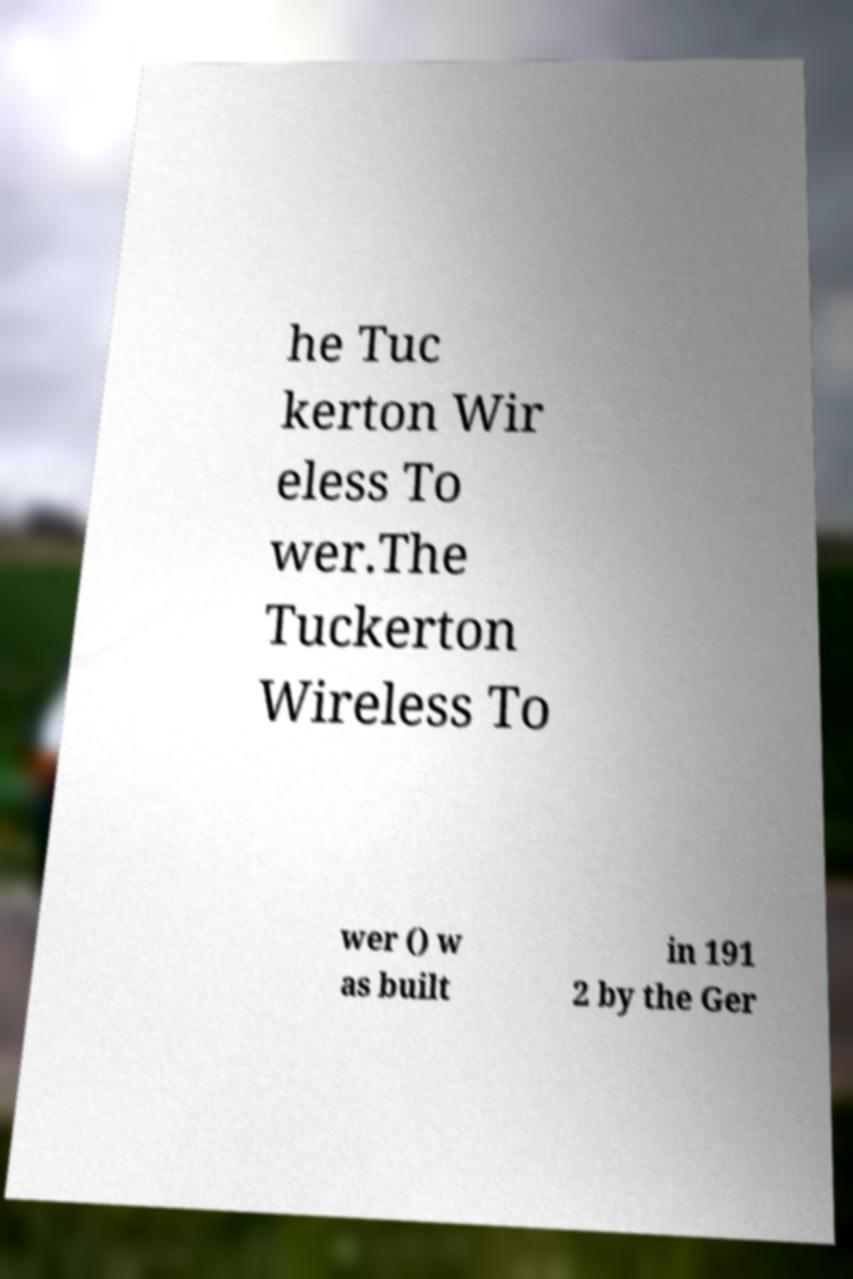For documentation purposes, I need the text within this image transcribed. Could you provide that? he Tuc kerton Wir eless To wer.The Tuckerton Wireless To wer () w as built in 191 2 by the Ger 